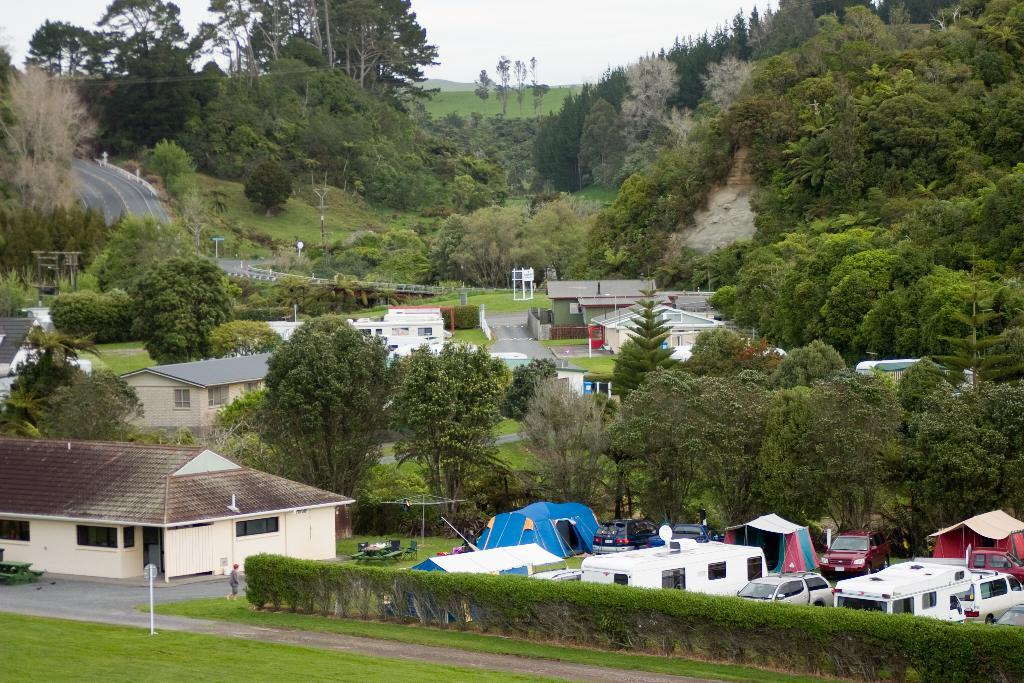What type of temporary shelters can be seen in the image? There are tents in the image. What mode of transportation can be seen in the image? There are vehicles in the image. What type of pathway is present in the image? There is a road in the image. What type of permanent structures can be seen in the image? There are houses in the image. What type of vertical structures can be seen in the image? There are poles in the image. What type of natural vegetation can be seen in the image? There are trees in the image. What part of the natural environment is visible in the background of the image? The sky is visible in the background of the image. What type of box is being used to cut materials in the image? There is no box or cutting activity present in the image. What type of camping activity is being performed in the image? There is no camping activity depicted in the image; it features tents, vehicles, a road, houses, poles, trees, and the sky. 